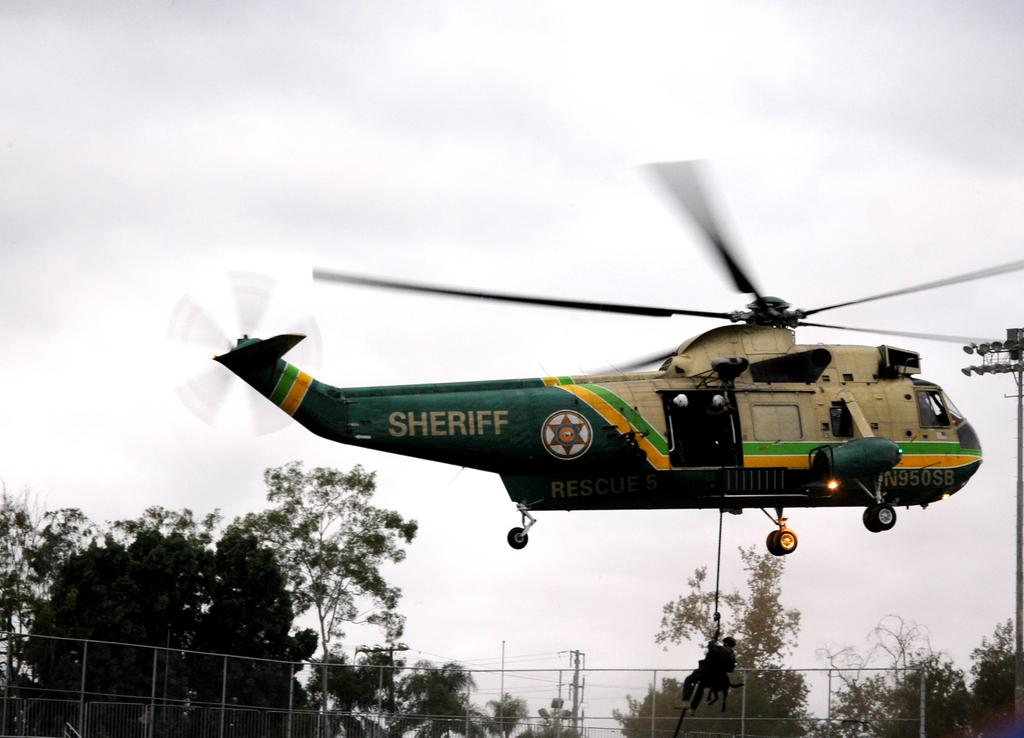<image>
Present a compact description of the photo's key features. A helicopter with the word sheriff on the side is in the air. 